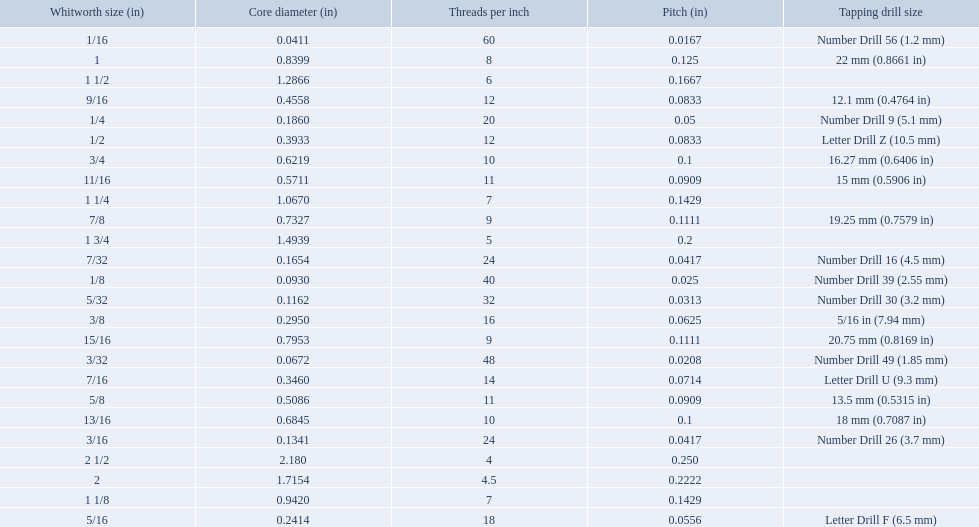What are all of the whitworth sizes? 1/16, 3/32, 1/8, 5/32, 3/16, 7/32, 1/4, 5/16, 3/8, 7/16, 1/2, 9/16, 5/8, 11/16, 3/4, 13/16, 7/8, 15/16, 1, 1 1/8, 1 1/4, 1 1/2, 1 3/4, 2, 2 1/2. How many threads per inch are in each size? 60, 48, 40, 32, 24, 24, 20, 18, 16, 14, 12, 12, 11, 11, 10, 10, 9, 9, 8, 7, 7, 6, 5, 4.5, 4. How many threads per inch are in the 3/16 size? 24. And which other size has the same number of threads? 7/32. 